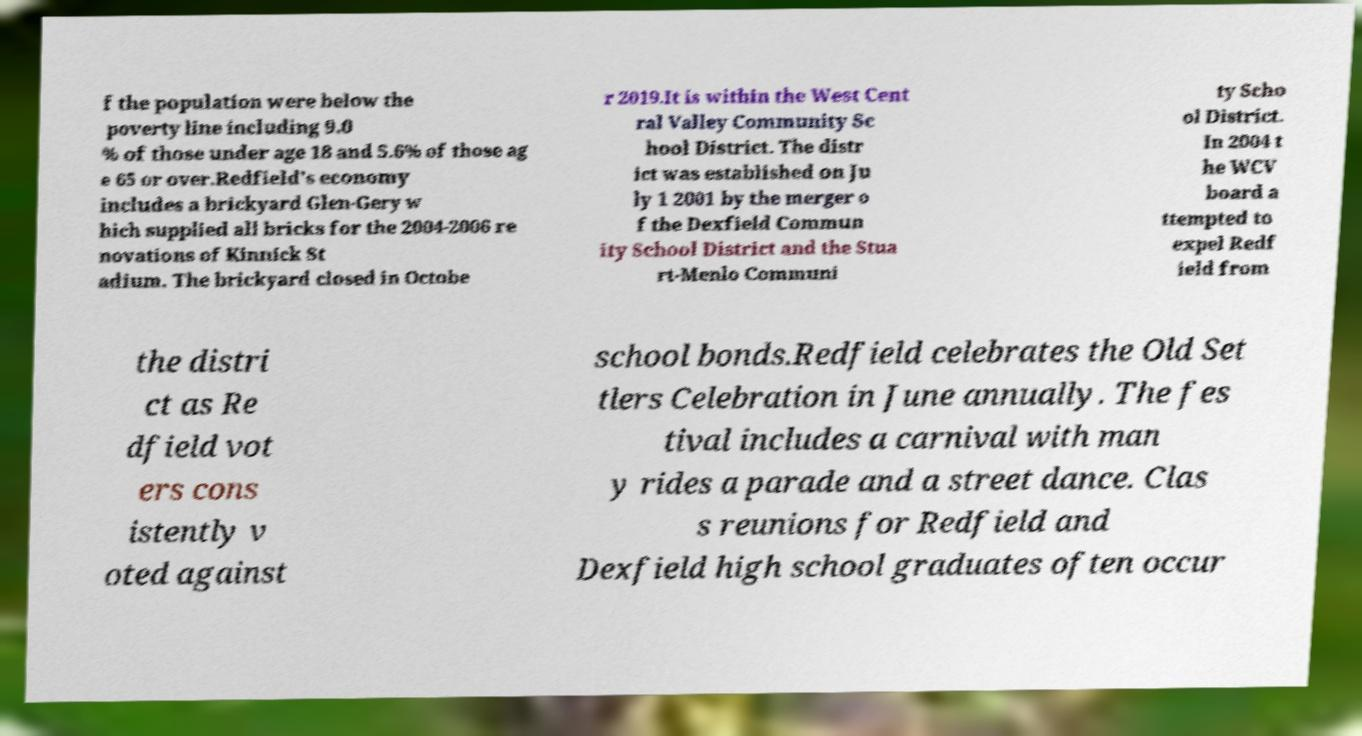Please read and relay the text visible in this image. What does it say? f the population were below the poverty line including 9.0 % of those under age 18 and 5.6% of those ag e 65 or over.Redfield's economy includes a brickyard Glen-Gery w hich supplied all bricks for the 2004-2006 re novations of Kinnick St adium. The brickyard closed in Octobe r 2019.It is within the West Cent ral Valley Community Sc hool District. The distr ict was established on Ju ly 1 2001 by the merger o f the Dexfield Commun ity School District and the Stua rt-Menlo Communi ty Scho ol District. In 2004 t he WCV board a ttempted to expel Redf ield from the distri ct as Re dfield vot ers cons istently v oted against school bonds.Redfield celebrates the Old Set tlers Celebration in June annually. The fes tival includes a carnival with man y rides a parade and a street dance. Clas s reunions for Redfield and Dexfield high school graduates often occur 